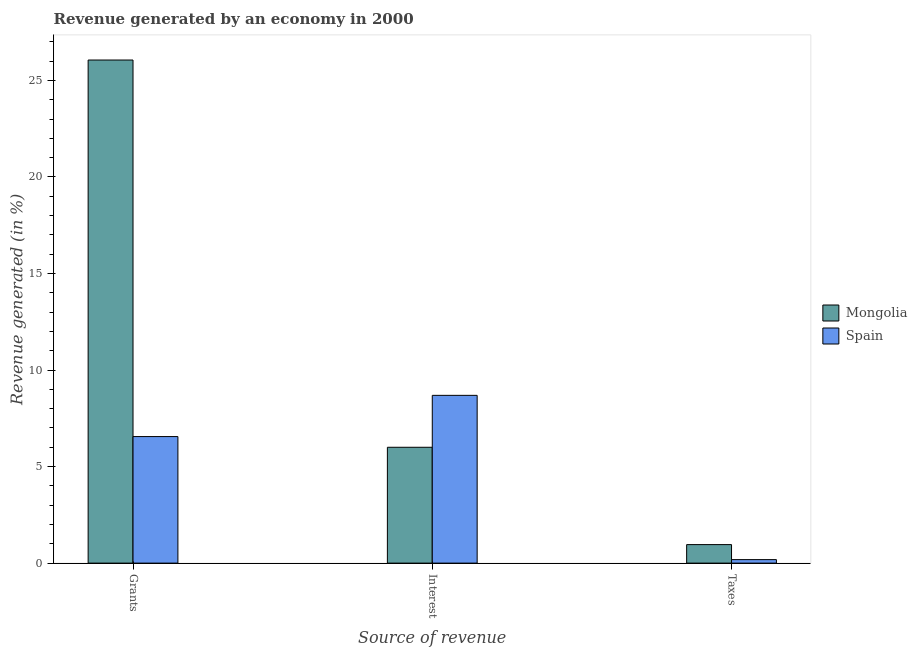How many different coloured bars are there?
Provide a succinct answer. 2. How many bars are there on the 1st tick from the left?
Keep it short and to the point. 2. How many bars are there on the 2nd tick from the right?
Provide a succinct answer. 2. What is the label of the 2nd group of bars from the left?
Your response must be concise. Interest. What is the percentage of revenue generated by taxes in Spain?
Offer a terse response. 0.18. Across all countries, what is the maximum percentage of revenue generated by interest?
Keep it short and to the point. 8.69. Across all countries, what is the minimum percentage of revenue generated by interest?
Your answer should be very brief. 6. In which country was the percentage of revenue generated by taxes maximum?
Your answer should be compact. Mongolia. What is the total percentage of revenue generated by interest in the graph?
Ensure brevity in your answer.  14.69. What is the difference between the percentage of revenue generated by interest in Spain and that in Mongolia?
Ensure brevity in your answer.  2.69. What is the difference between the percentage of revenue generated by taxes in Spain and the percentage of revenue generated by grants in Mongolia?
Ensure brevity in your answer.  -25.87. What is the average percentage of revenue generated by taxes per country?
Offer a very short reply. 0.57. What is the difference between the percentage of revenue generated by interest and percentage of revenue generated by grants in Mongolia?
Your response must be concise. -20.06. In how many countries, is the percentage of revenue generated by interest greater than 10 %?
Make the answer very short. 0. What is the ratio of the percentage of revenue generated by taxes in Spain to that in Mongolia?
Ensure brevity in your answer.  0.19. Is the percentage of revenue generated by grants in Spain less than that in Mongolia?
Give a very brief answer. Yes. Is the difference between the percentage of revenue generated by taxes in Spain and Mongolia greater than the difference between the percentage of revenue generated by interest in Spain and Mongolia?
Give a very brief answer. No. What is the difference between the highest and the second highest percentage of revenue generated by interest?
Ensure brevity in your answer.  2.69. What is the difference between the highest and the lowest percentage of revenue generated by taxes?
Offer a terse response. 0.78. Is the sum of the percentage of revenue generated by grants in Spain and Mongolia greater than the maximum percentage of revenue generated by interest across all countries?
Provide a succinct answer. Yes. What does the 1st bar from the right in Interest represents?
Offer a very short reply. Spain. Is it the case that in every country, the sum of the percentage of revenue generated by grants and percentage of revenue generated by interest is greater than the percentage of revenue generated by taxes?
Offer a very short reply. Yes. How many bars are there?
Your answer should be very brief. 6. Are all the bars in the graph horizontal?
Keep it short and to the point. No. How many countries are there in the graph?
Give a very brief answer. 2. What is the difference between two consecutive major ticks on the Y-axis?
Provide a succinct answer. 5. Are the values on the major ticks of Y-axis written in scientific E-notation?
Offer a terse response. No. Where does the legend appear in the graph?
Make the answer very short. Center right. How many legend labels are there?
Your response must be concise. 2. What is the title of the graph?
Your answer should be very brief. Revenue generated by an economy in 2000. What is the label or title of the X-axis?
Offer a very short reply. Source of revenue. What is the label or title of the Y-axis?
Offer a terse response. Revenue generated (in %). What is the Revenue generated (in %) of Mongolia in Grants?
Give a very brief answer. 26.05. What is the Revenue generated (in %) in Spain in Grants?
Ensure brevity in your answer.  6.55. What is the Revenue generated (in %) of Mongolia in Interest?
Keep it short and to the point. 6. What is the Revenue generated (in %) of Spain in Interest?
Make the answer very short. 8.69. What is the Revenue generated (in %) in Mongolia in Taxes?
Provide a succinct answer. 0.96. What is the Revenue generated (in %) in Spain in Taxes?
Offer a very short reply. 0.18. Across all Source of revenue, what is the maximum Revenue generated (in %) in Mongolia?
Ensure brevity in your answer.  26.05. Across all Source of revenue, what is the maximum Revenue generated (in %) of Spain?
Offer a very short reply. 8.69. Across all Source of revenue, what is the minimum Revenue generated (in %) in Mongolia?
Provide a succinct answer. 0.96. Across all Source of revenue, what is the minimum Revenue generated (in %) of Spain?
Offer a very short reply. 0.18. What is the total Revenue generated (in %) in Mongolia in the graph?
Your answer should be very brief. 33.01. What is the total Revenue generated (in %) in Spain in the graph?
Offer a terse response. 15.42. What is the difference between the Revenue generated (in %) in Mongolia in Grants and that in Interest?
Offer a very short reply. 20.06. What is the difference between the Revenue generated (in %) in Spain in Grants and that in Interest?
Provide a short and direct response. -2.13. What is the difference between the Revenue generated (in %) in Mongolia in Grants and that in Taxes?
Offer a terse response. 25.1. What is the difference between the Revenue generated (in %) of Spain in Grants and that in Taxes?
Provide a short and direct response. 6.37. What is the difference between the Revenue generated (in %) of Mongolia in Interest and that in Taxes?
Keep it short and to the point. 5.04. What is the difference between the Revenue generated (in %) in Spain in Interest and that in Taxes?
Provide a succinct answer. 8.51. What is the difference between the Revenue generated (in %) in Mongolia in Grants and the Revenue generated (in %) in Spain in Interest?
Keep it short and to the point. 17.37. What is the difference between the Revenue generated (in %) of Mongolia in Grants and the Revenue generated (in %) of Spain in Taxes?
Your answer should be very brief. 25.87. What is the difference between the Revenue generated (in %) in Mongolia in Interest and the Revenue generated (in %) in Spain in Taxes?
Provide a short and direct response. 5.82. What is the average Revenue generated (in %) in Mongolia per Source of revenue?
Your response must be concise. 11. What is the average Revenue generated (in %) of Spain per Source of revenue?
Your answer should be compact. 5.14. What is the difference between the Revenue generated (in %) in Mongolia and Revenue generated (in %) in Spain in Grants?
Provide a short and direct response. 19.5. What is the difference between the Revenue generated (in %) in Mongolia and Revenue generated (in %) in Spain in Interest?
Offer a very short reply. -2.69. What is the difference between the Revenue generated (in %) in Mongolia and Revenue generated (in %) in Spain in Taxes?
Provide a short and direct response. 0.78. What is the ratio of the Revenue generated (in %) of Mongolia in Grants to that in Interest?
Offer a very short reply. 4.34. What is the ratio of the Revenue generated (in %) in Spain in Grants to that in Interest?
Give a very brief answer. 0.75. What is the ratio of the Revenue generated (in %) of Mongolia in Grants to that in Taxes?
Your response must be concise. 27.17. What is the ratio of the Revenue generated (in %) in Spain in Grants to that in Taxes?
Offer a terse response. 36.24. What is the ratio of the Revenue generated (in %) in Mongolia in Interest to that in Taxes?
Give a very brief answer. 6.26. What is the ratio of the Revenue generated (in %) in Spain in Interest to that in Taxes?
Offer a very short reply. 48.05. What is the difference between the highest and the second highest Revenue generated (in %) of Mongolia?
Your response must be concise. 20.06. What is the difference between the highest and the second highest Revenue generated (in %) of Spain?
Give a very brief answer. 2.13. What is the difference between the highest and the lowest Revenue generated (in %) in Mongolia?
Give a very brief answer. 25.1. What is the difference between the highest and the lowest Revenue generated (in %) in Spain?
Ensure brevity in your answer.  8.51. 